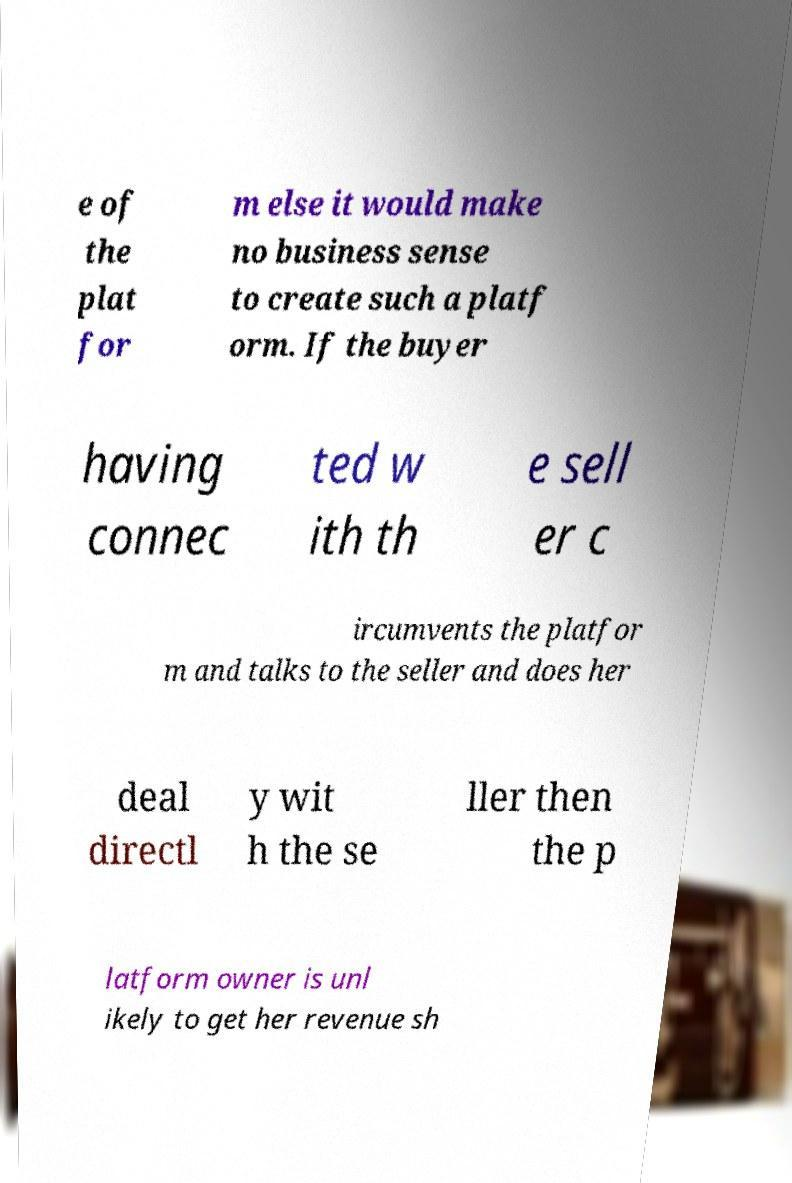Can you read and provide the text displayed in the image?This photo seems to have some interesting text. Can you extract and type it out for me? e of the plat for m else it would make no business sense to create such a platf orm. If the buyer having connec ted w ith th e sell er c ircumvents the platfor m and talks to the seller and does her deal directl y wit h the se ller then the p latform owner is unl ikely to get her revenue sh 